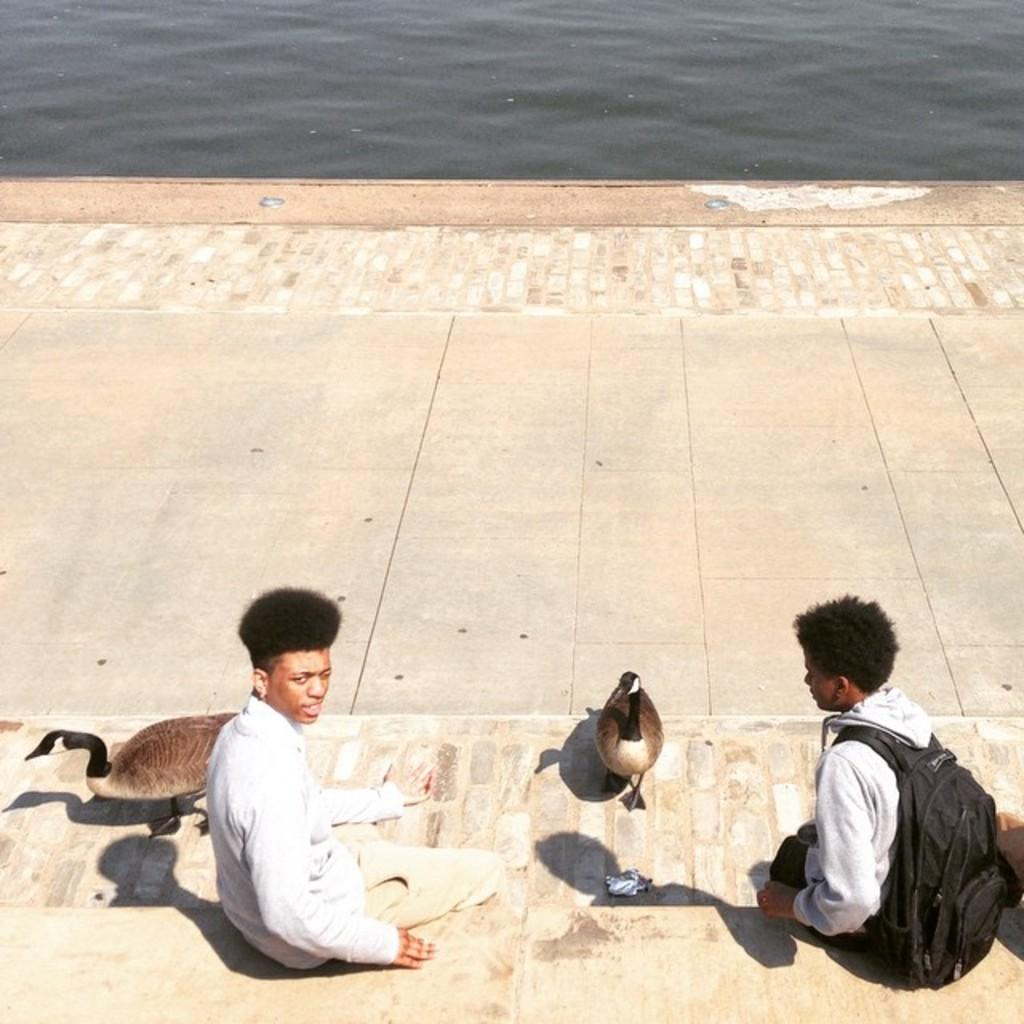How many boys are present in the image? There are two boys sitting in the image. What animals are also present in the image? There are two swans in the image. What can be seen in the background of the image? There is water visible in the background of the image. What type of pail is being used by the swans to collect water in the image? There is no pail present in the image, and the swans are not collecting water. 